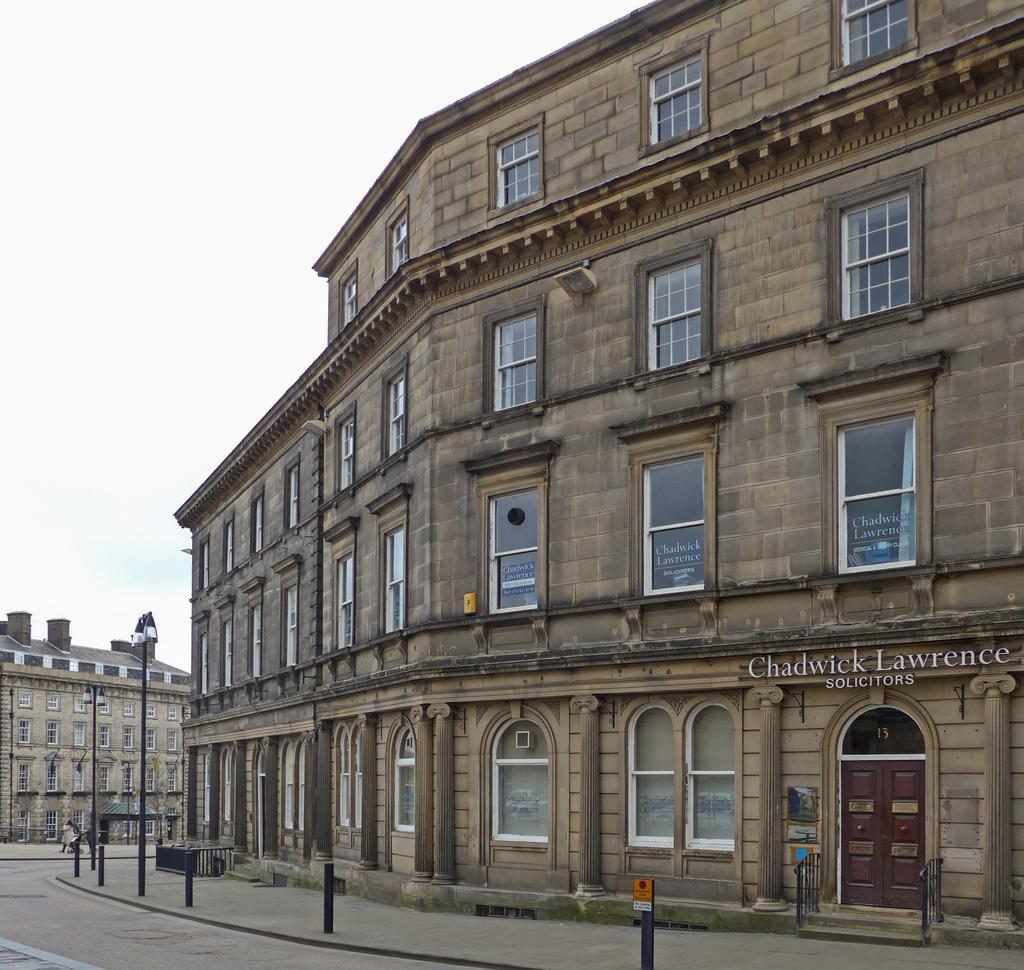How would you summarize this image in a sentence or two? In this image we can see two buildings. On the buildings we can see few windows. On the right side we can see text on few windows and building. We can see a door on the right side of the image. In front of the building we can see few poles with lights, persons and barriers. At the top we can see the sky. 